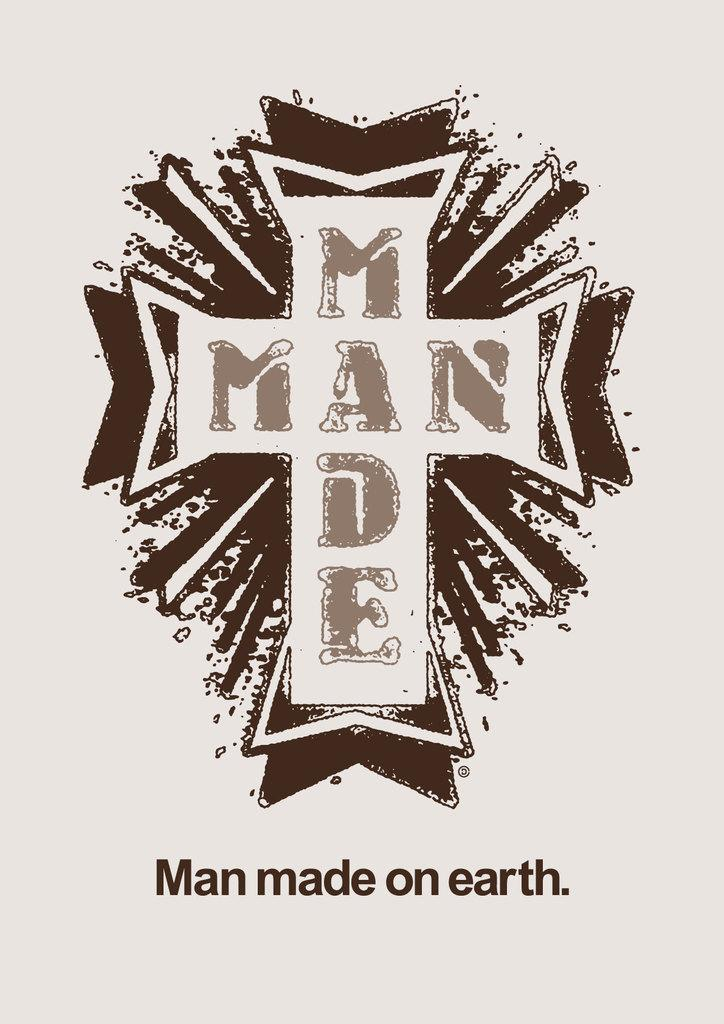<image>
Write a terse but informative summary of the picture. a white cross with brown shades around it and man made on earth written below it 